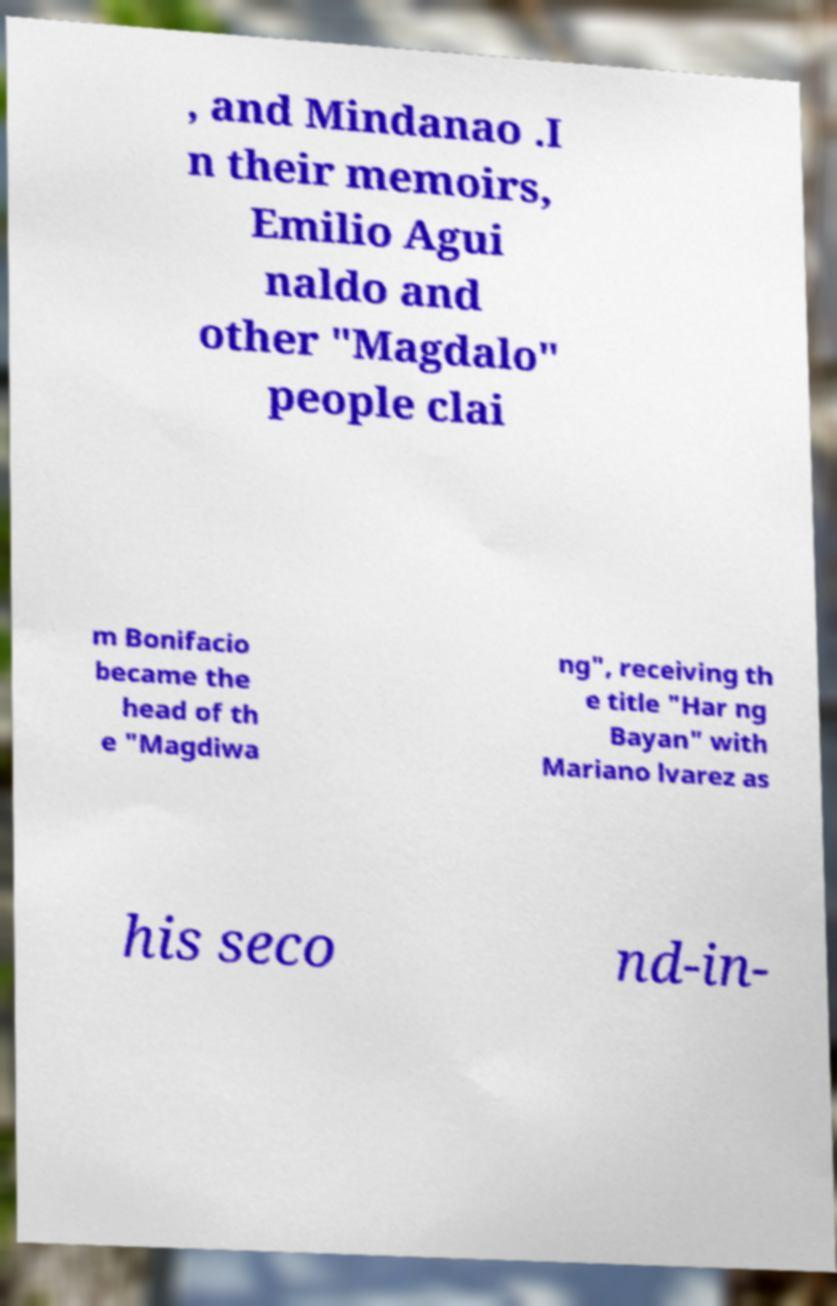Could you extract and type out the text from this image? , and Mindanao .I n their memoirs, Emilio Agui naldo and other "Magdalo" people clai m Bonifacio became the head of th e "Magdiwa ng", receiving th e title "Har ng Bayan" with Mariano lvarez as his seco nd-in- 